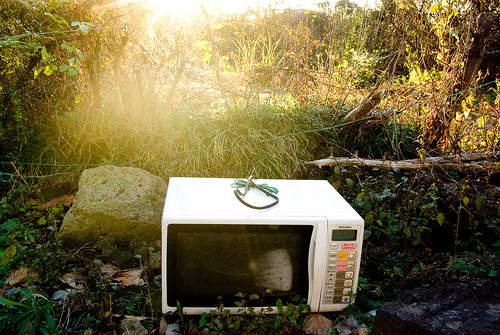<image>What brand microwave is this? It is unknown what brand the microwave is. It could potentially be Maytag, GE, RCA or Kenmore. What brand microwave is this? I don't know what brand microwave it is. It can be either old, Maytag, unknown, B&D, GE, Samsung, RCA, or Kenmore. 